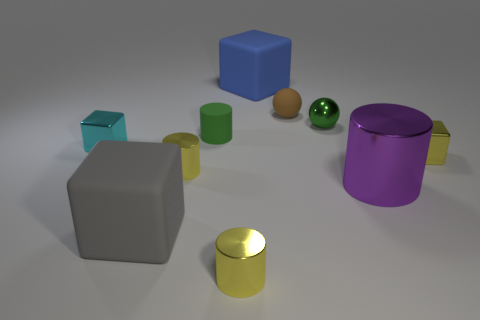Subtract all gray rubber blocks. How many blocks are left? 3 Subtract all green cylinders. How many cylinders are left? 3 Subtract all cylinders. How many objects are left? 6 Subtract 1 cylinders. How many cylinders are left? 3 Add 4 yellow cylinders. How many yellow cylinders are left? 6 Add 8 tiny green matte cylinders. How many tiny green matte cylinders exist? 9 Subtract 0 yellow balls. How many objects are left? 10 Subtract all green cubes. Subtract all yellow cylinders. How many cubes are left? 4 Subtract all blue blocks. How many brown spheres are left? 1 Subtract all large blue metallic balls. Subtract all tiny rubber objects. How many objects are left? 8 